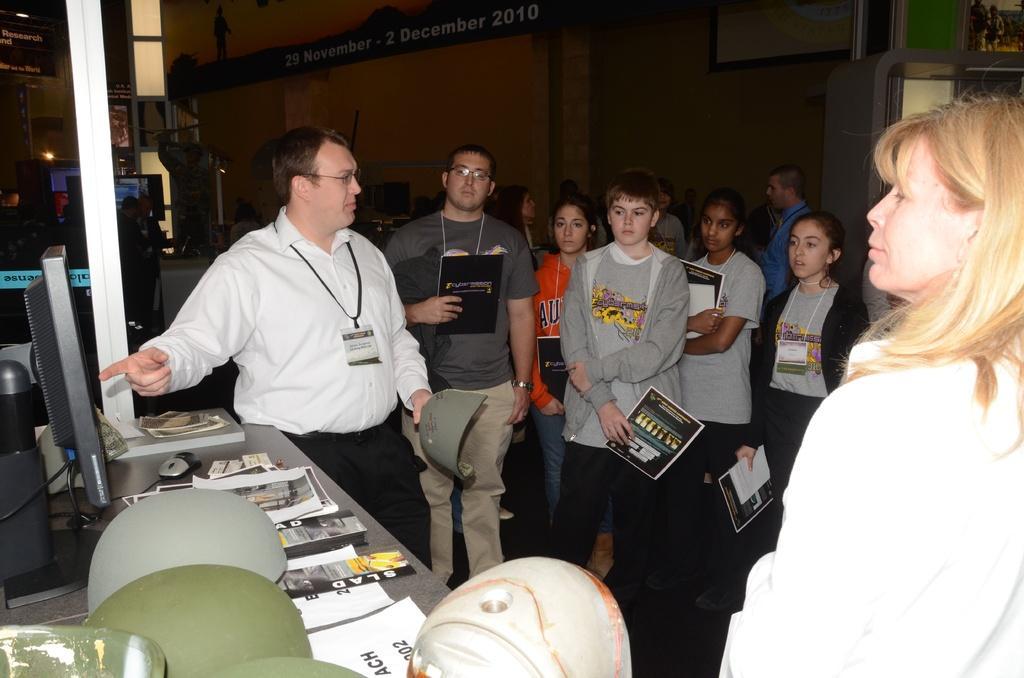Please provide a concise description of this image. In this picture there are people those who are standing in the center of the image, by holding books in there hands and there is a table in the bottom left side of the image, on which there is a monitor, mouse, and books on it, there are posters and windows in the background area of the image. 